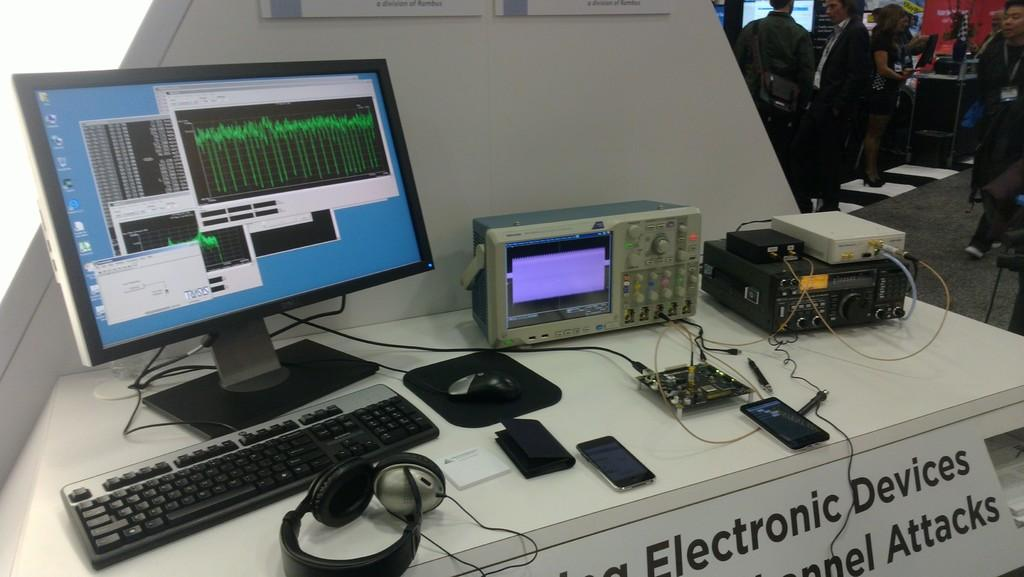<image>
Share a concise interpretation of the image provided. A computer standing on table that says Electronic Devices on the front. 